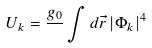<formula> <loc_0><loc_0><loc_500><loc_500>U _ { k } = \frac { g _ { 0 } } { } \int d { \vec { r } } \, | \Phi _ { k } | ^ { 4 } \,</formula> 